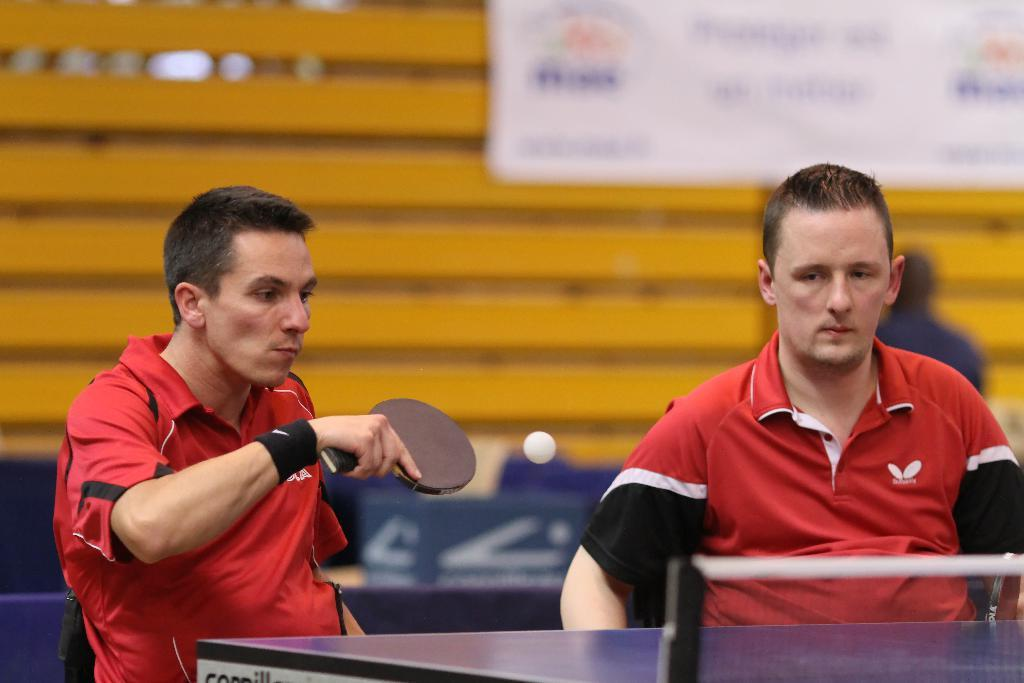How many people are in the image? There are two men in the image. What are the men doing in the image? The men are playing table tennis. What are the men sitting on while playing table tennis? The men are sitting in chairs. What can be seen in the background of the image? There is a poster and a wall-like structure made of wood in the background of the image. Can you tell me where the cable is plugged in for the kettle in the image? There is no cable or kettle present in the image. What type of fang can be seen on the men playing table tennis? There are no fangs present in the image; the men are playing table tennis without any animal-like features. 